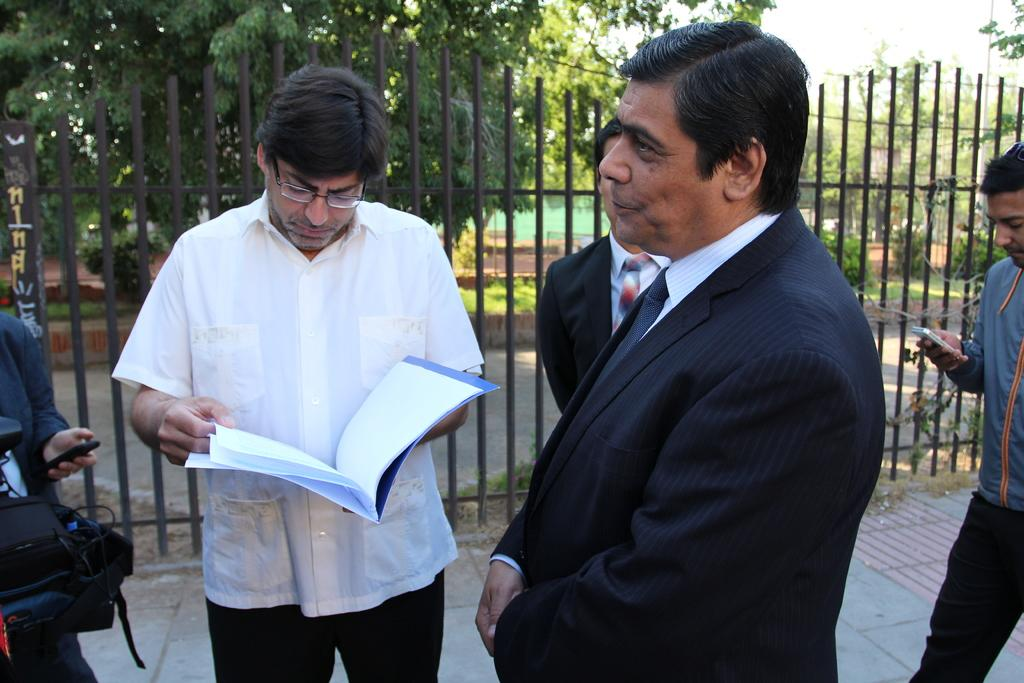What is the man in the image holding? The man is holding a book in the image. Who is standing near the man? There is a group of people standing beside the man. What can be seen in the background of the image? In the background of the image, there is a bag, a mobile, trees, plants, a building, and the sky. What type of fear can be seen on the faces of the mice in the image? There are no mice present in the image, so it is not possible to determine any fear on their faces. 